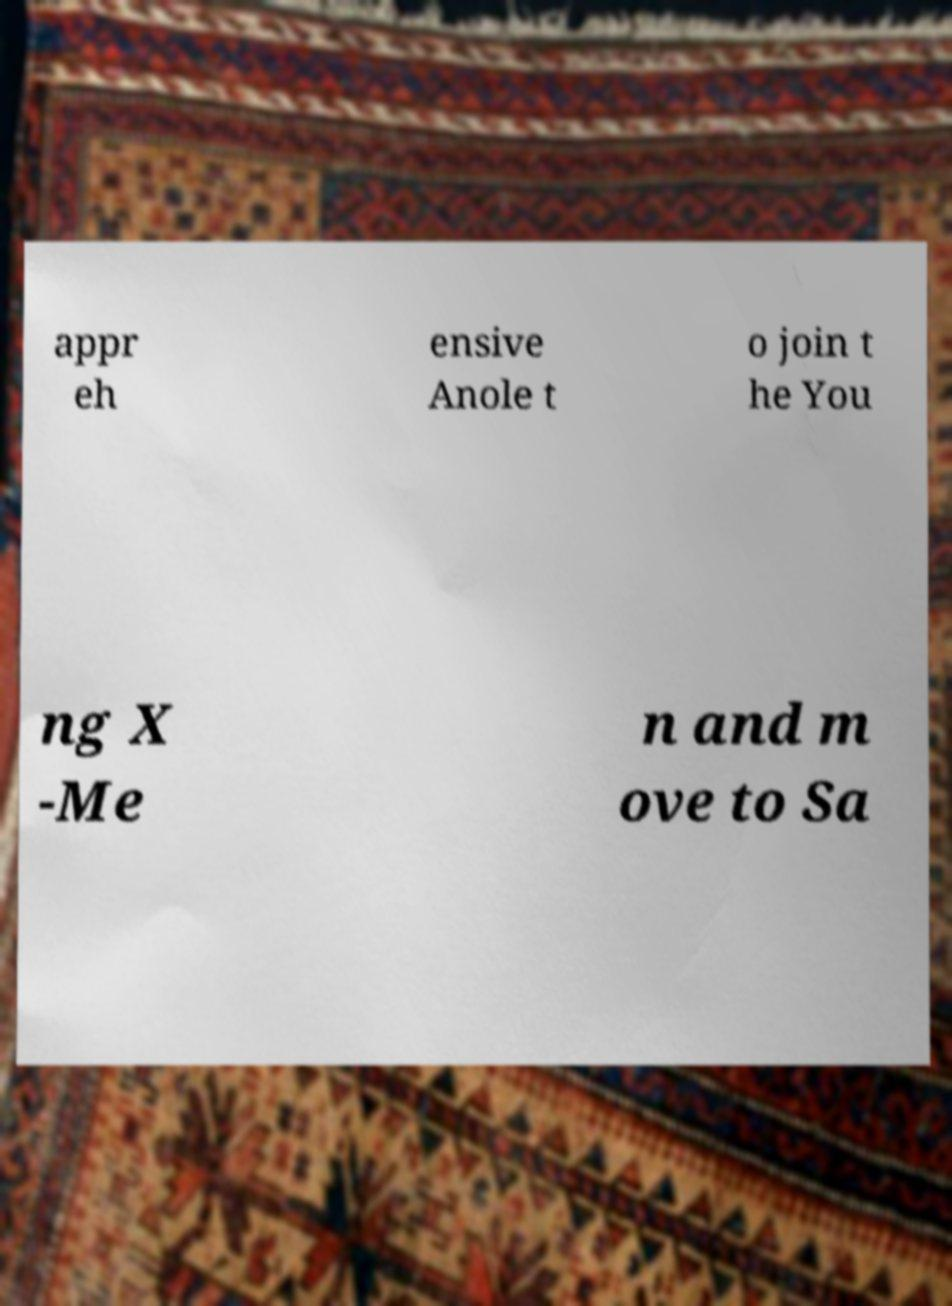Can you accurately transcribe the text from the provided image for me? appr eh ensive Anole t o join t he You ng X -Me n and m ove to Sa 